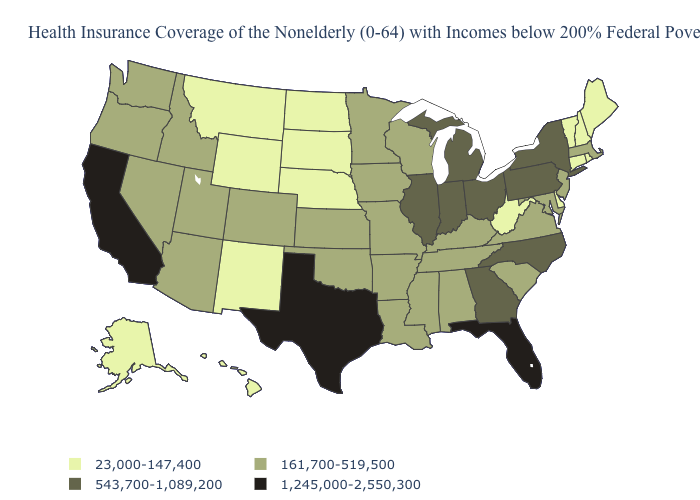Does Mississippi have the highest value in the USA?
Write a very short answer. No. Which states have the lowest value in the MidWest?
Give a very brief answer. Nebraska, North Dakota, South Dakota. What is the highest value in the USA?
Be succinct. 1,245,000-2,550,300. Among the states that border West Virginia , does Pennsylvania have the lowest value?
Keep it brief. No. What is the value of Alaska?
Concise answer only. 23,000-147,400. Name the states that have a value in the range 543,700-1,089,200?
Keep it brief. Georgia, Illinois, Indiana, Michigan, New York, North Carolina, Ohio, Pennsylvania. What is the highest value in the West ?
Answer briefly. 1,245,000-2,550,300. Name the states that have a value in the range 1,245,000-2,550,300?
Short answer required. California, Florida, Texas. What is the lowest value in states that border New Mexico?
Write a very short answer. 161,700-519,500. Name the states that have a value in the range 1,245,000-2,550,300?
Answer briefly. California, Florida, Texas. Name the states that have a value in the range 161,700-519,500?
Concise answer only. Alabama, Arizona, Arkansas, Colorado, Idaho, Iowa, Kansas, Kentucky, Louisiana, Maryland, Massachusetts, Minnesota, Mississippi, Missouri, Nevada, New Jersey, Oklahoma, Oregon, South Carolina, Tennessee, Utah, Virginia, Washington, Wisconsin. Does the map have missing data?
Short answer required. No. Is the legend a continuous bar?
Short answer required. No. Does the first symbol in the legend represent the smallest category?
Answer briefly. Yes. 